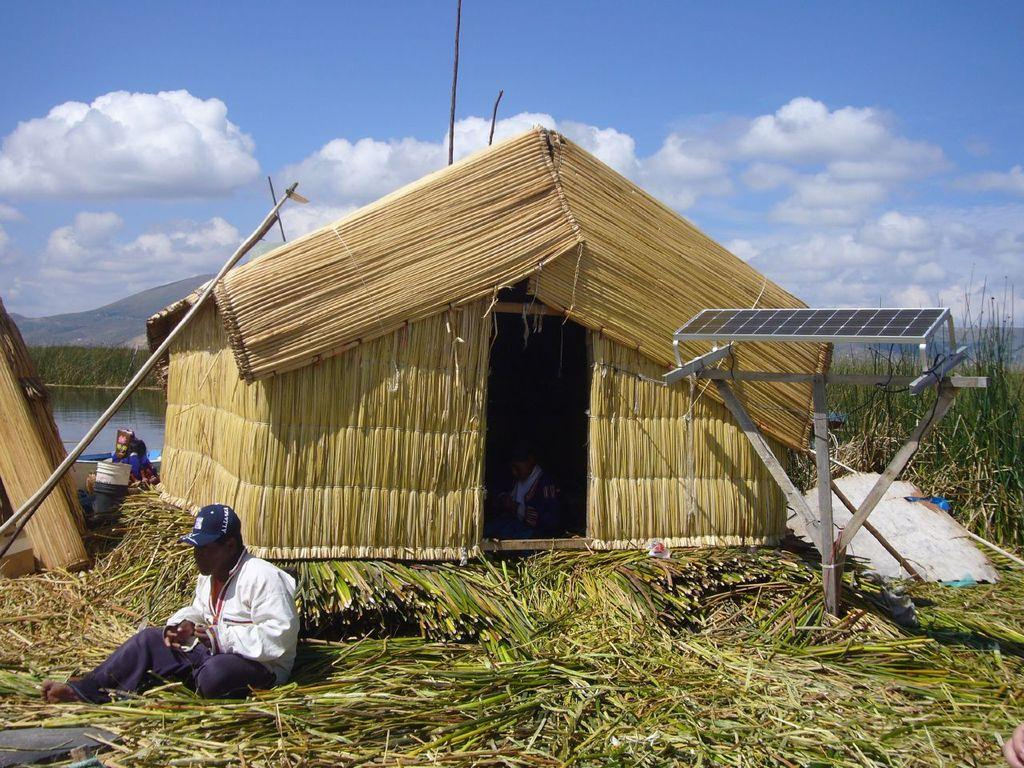Where was the image taken? The image was clicked outside. What can be seen on the left side of the image? There is a person and water on the left side of the image. What is located in the middle of the image? There is a small hut in the middle of the image. What is visible at the top of the image? The sky is visible at the top of the image. What mathematical operation is being performed by the person in the image? There is no indication in the image that the person is performing any mathematical operation. Can you tell me how many times the person in the image has talked to the hut? There is no interaction between the person and the hut in the image, so it is not possible to determine how many times they have talked. 